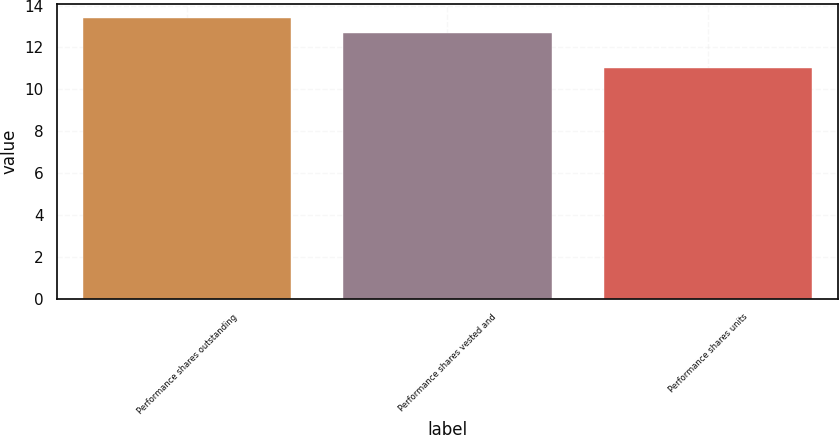Convert chart to OTSL. <chart><loc_0><loc_0><loc_500><loc_500><bar_chart><fcel>Performance shares outstanding<fcel>Performance shares vested and<fcel>Performance shares units<nl><fcel>13.4<fcel>12.7<fcel>11<nl></chart> 